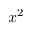Convert formula to latex. <formula><loc_0><loc_0><loc_500><loc_500>x ^ { 2 }</formula> 